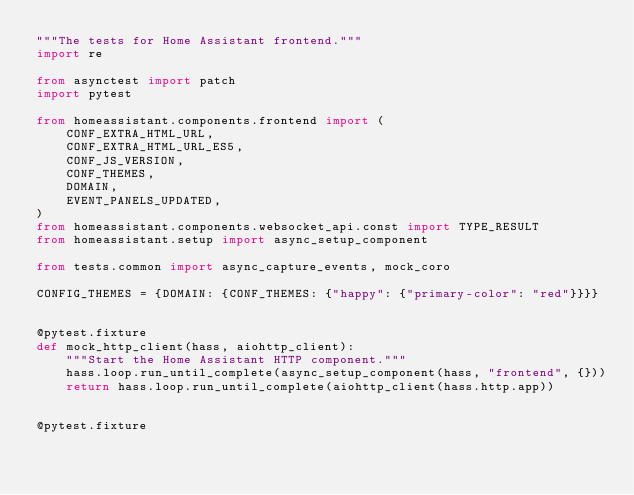Convert code to text. <code><loc_0><loc_0><loc_500><loc_500><_Python_>"""The tests for Home Assistant frontend."""
import re

from asynctest import patch
import pytest

from homeassistant.components.frontend import (
    CONF_EXTRA_HTML_URL,
    CONF_EXTRA_HTML_URL_ES5,
    CONF_JS_VERSION,
    CONF_THEMES,
    DOMAIN,
    EVENT_PANELS_UPDATED,
)
from homeassistant.components.websocket_api.const import TYPE_RESULT
from homeassistant.setup import async_setup_component

from tests.common import async_capture_events, mock_coro

CONFIG_THEMES = {DOMAIN: {CONF_THEMES: {"happy": {"primary-color": "red"}}}}


@pytest.fixture
def mock_http_client(hass, aiohttp_client):
    """Start the Home Assistant HTTP component."""
    hass.loop.run_until_complete(async_setup_component(hass, "frontend", {}))
    return hass.loop.run_until_complete(aiohttp_client(hass.http.app))


@pytest.fixture</code> 